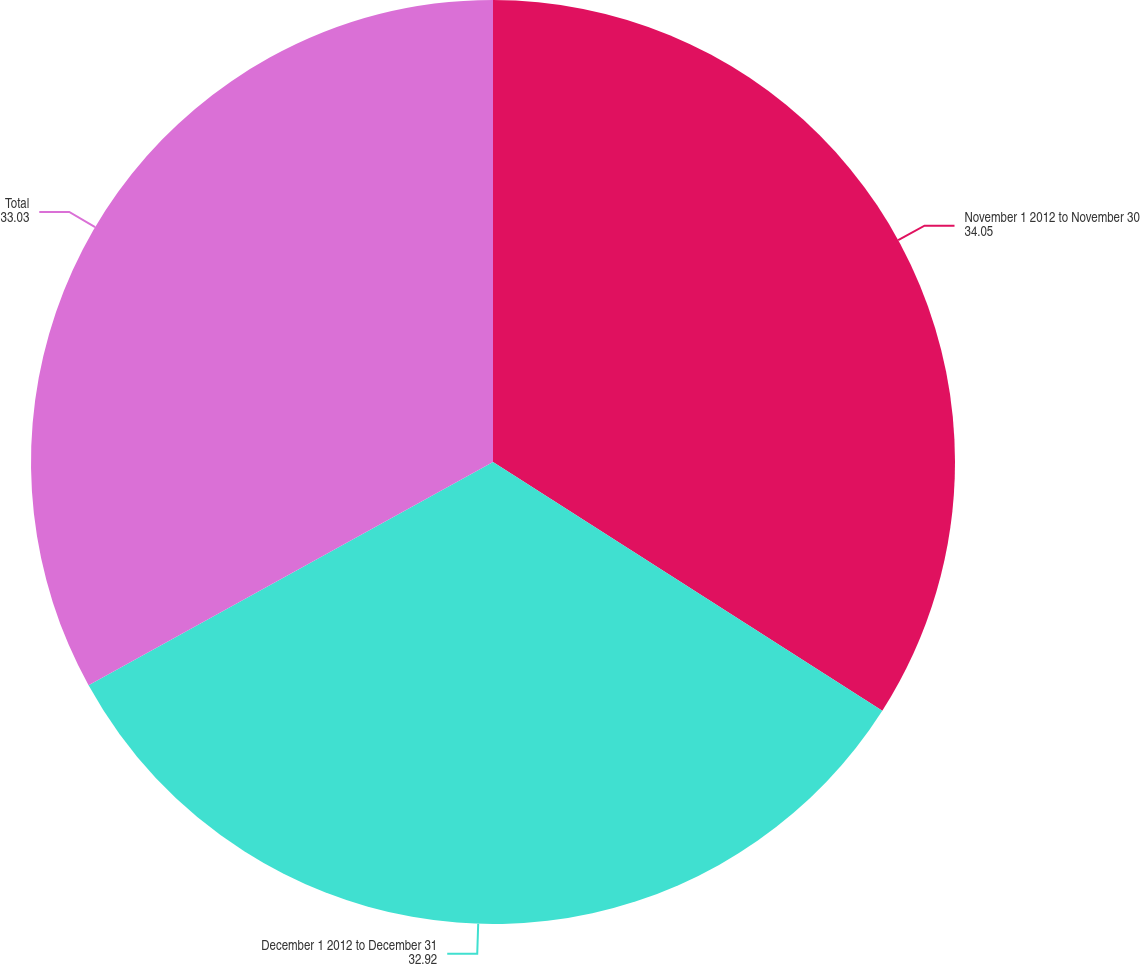<chart> <loc_0><loc_0><loc_500><loc_500><pie_chart><fcel>November 1 2012 to November 30<fcel>December 1 2012 to December 31<fcel>Total<nl><fcel>34.05%<fcel>32.92%<fcel>33.03%<nl></chart> 